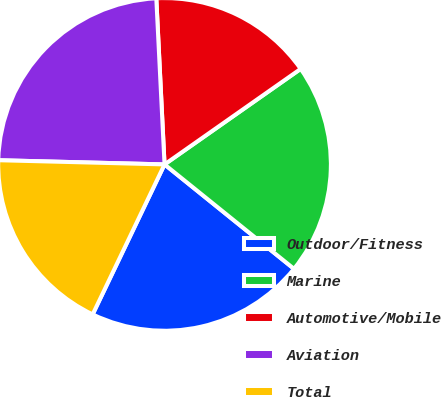Convert chart. <chart><loc_0><loc_0><loc_500><loc_500><pie_chart><fcel>Outdoor/Fitness<fcel>Marine<fcel>Automotive/Mobile<fcel>Aviation<fcel>Total<nl><fcel>21.31%<fcel>20.54%<fcel>16.05%<fcel>23.81%<fcel>18.29%<nl></chart> 